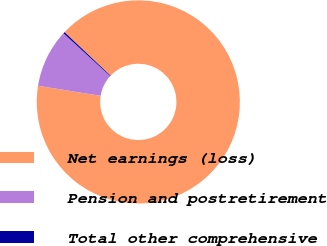<chart> <loc_0><loc_0><loc_500><loc_500><pie_chart><fcel>Net earnings (loss)<fcel>Pension and postretirement<fcel>Total other comprehensive<nl><fcel>90.49%<fcel>9.27%<fcel>0.24%<nl></chart> 